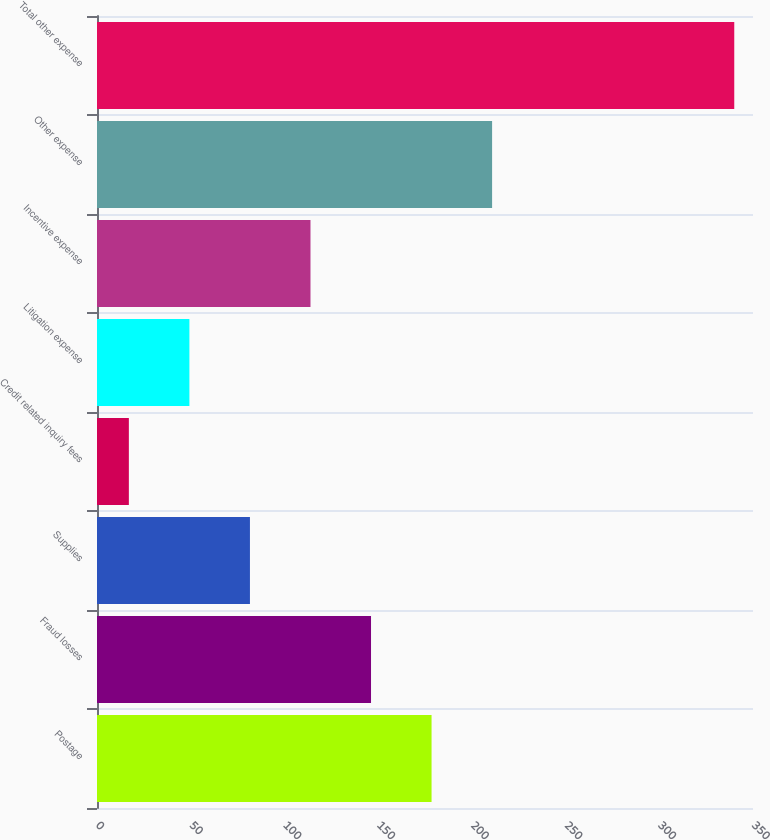<chart> <loc_0><loc_0><loc_500><loc_500><bar_chart><fcel>Postage<fcel>Fraud losses<fcel>Supplies<fcel>Credit related inquiry fees<fcel>Litigation expense<fcel>Incentive expense<fcel>Other expense<fcel>Total other expense<nl><fcel>178.5<fcel>146.2<fcel>81.6<fcel>17<fcel>49.3<fcel>113.9<fcel>210.8<fcel>340<nl></chart> 